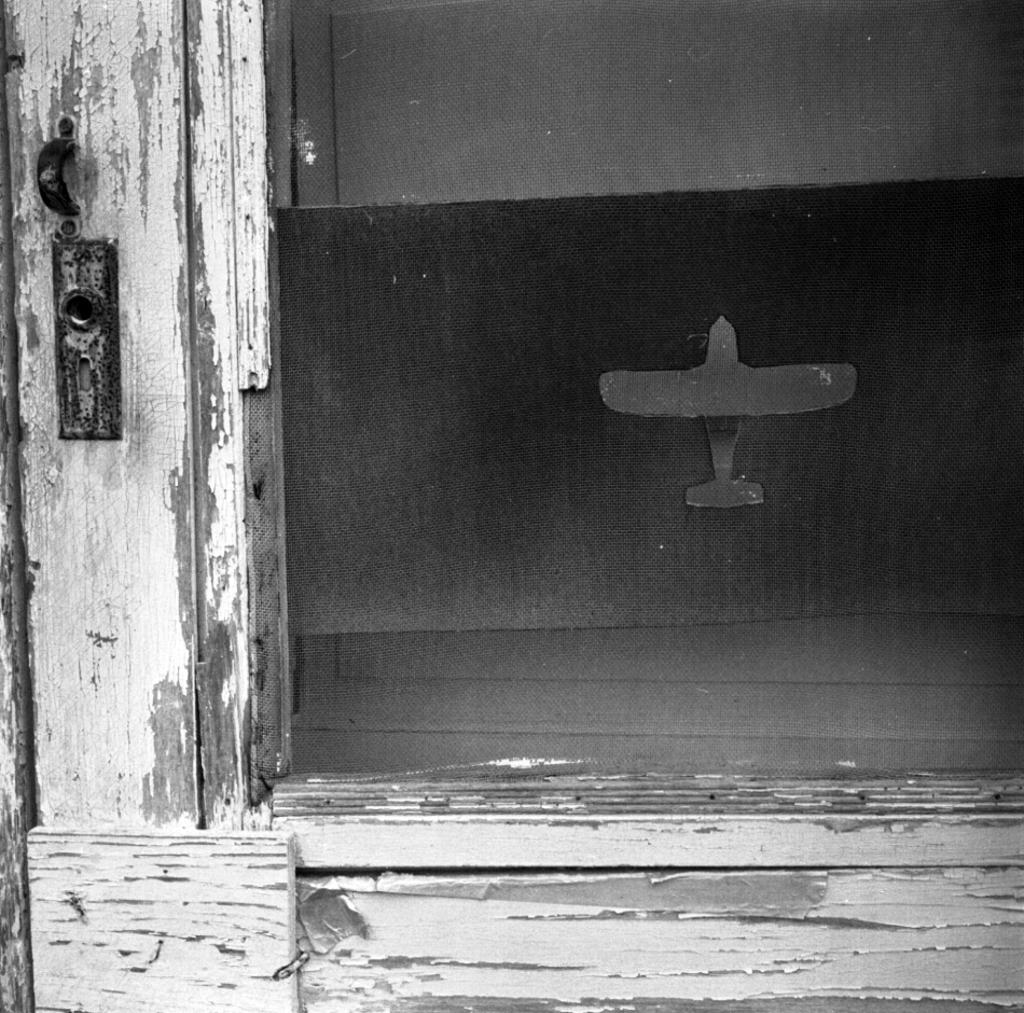What type of door is shown in the image? There is a wooden door in the image. Is there anything attached to the door? Yes, there is a holder attached to the door. What can be seen on the glass of the door? There is a picture of a plane on the glass of the door. What type of produce is being sold at the playground in the image? There is no playground or produce present in the image; it features a wooden door with a holder and a picture of a plane on the glass. 